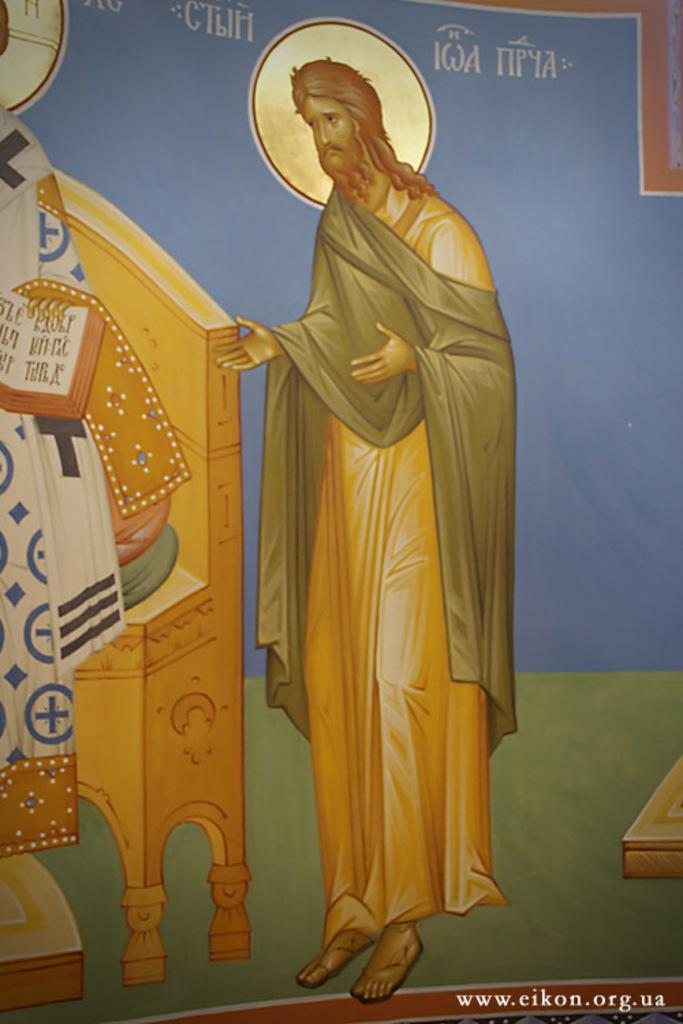What is the main subject of the image? There is a painting in the image. What is the painting depicting? The painting depicts a man. Can you describe the man's position in the painting? The man is standing near a desk in the painting. How many books can be seen on the man's knee in the painting? There are no books visible on the man's knee in the painting. What type of spoon is the man holding in the painting? The man is not holding a spoon in the painting. 